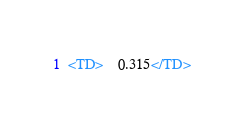Convert code to text. <code><loc_0><loc_0><loc_500><loc_500><_XML_><TD>    0.315</TD></code> 